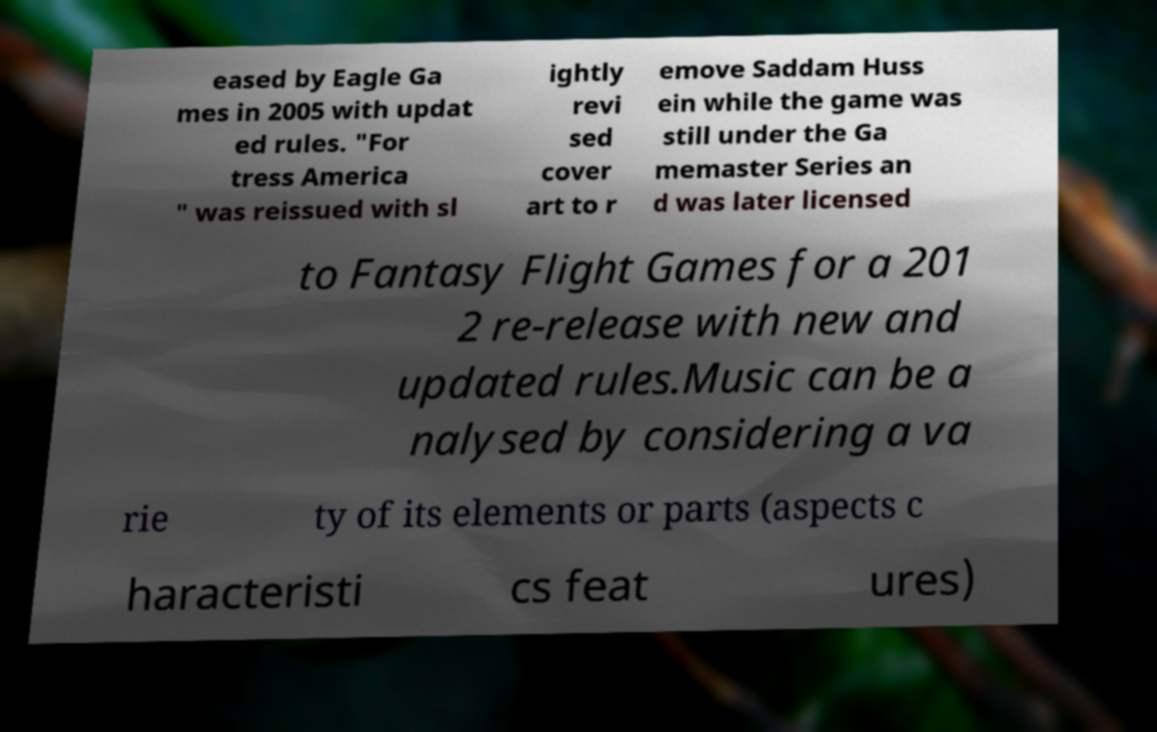For documentation purposes, I need the text within this image transcribed. Could you provide that? eased by Eagle Ga mes in 2005 with updat ed rules. "For tress America " was reissued with sl ightly revi sed cover art to r emove Saddam Huss ein while the game was still under the Ga memaster Series an d was later licensed to Fantasy Flight Games for a 201 2 re-release with new and updated rules.Music can be a nalysed by considering a va rie ty of its elements or parts (aspects c haracteristi cs feat ures) 